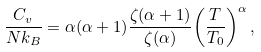Convert formula to latex. <formula><loc_0><loc_0><loc_500><loc_500>\frac { C _ { v } } { N k _ { B } } = \alpha ( \alpha + 1 ) \frac { \zeta ( \alpha + 1 ) } { \zeta ( \alpha ) } { \left ( \frac { T } { T _ { 0 } } \right ) } ^ { \alpha } \, ,</formula> 